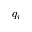Convert formula to latex. <formula><loc_0><loc_0><loc_500><loc_500>q _ { i }</formula> 